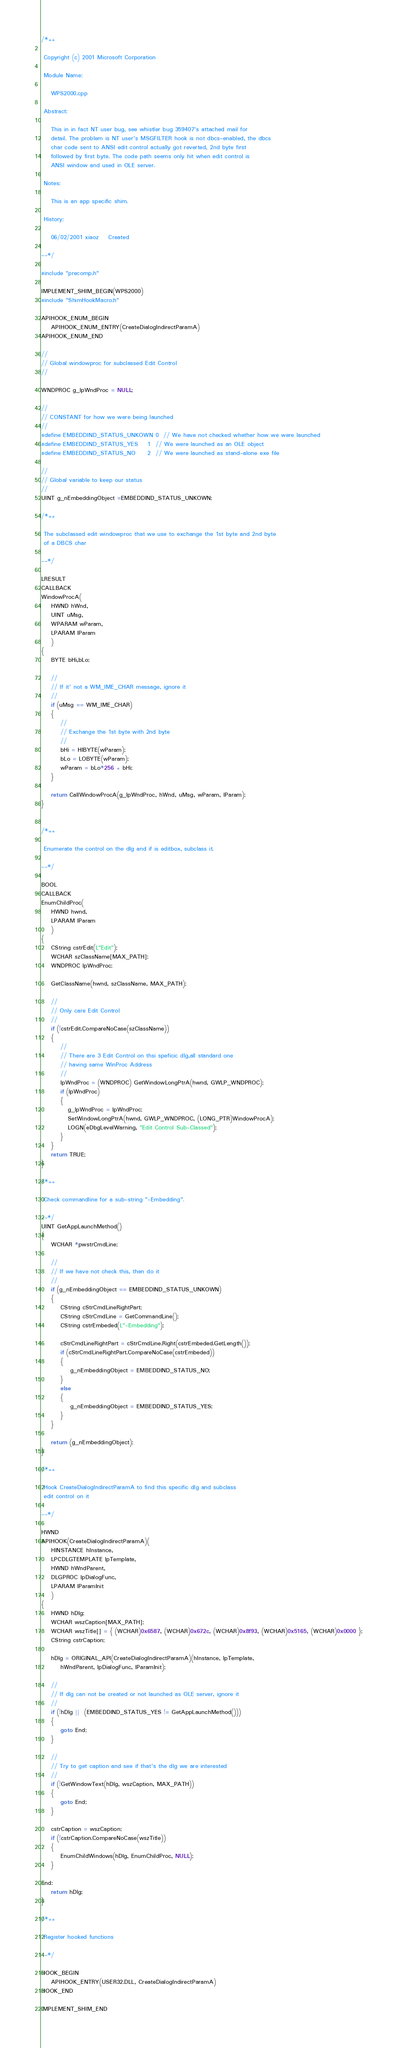<code> <loc_0><loc_0><loc_500><loc_500><_C++_>/*++

 Copyright (c) 2001 Microsoft Corporation

 Module Name:

    WPS2000.cpp

 Abstract:

    This in in fact NT user bug, see whistler bug 359407's attached mail for 
    detail. The problem is NT user's MSGFILTER hook is not dbcs-enabled, the dbcs 
    char code sent to ANSI edit control actually got reverted, 2nd byte first 
    followed by first byte. The code path seems only hit when edit control is 
    ANSI window and used in OLE server.

 Notes: 
  
    This is an app specific shim.

 History:

    06/02/2001 xiaoz    Created

--*/

#include "precomp.h"

IMPLEMENT_SHIM_BEGIN(WPS2000)
#include "ShimHookMacro.h"

APIHOOK_ENUM_BEGIN
    APIHOOK_ENUM_ENTRY(CreateDialogIndirectParamA) 
APIHOOK_ENUM_END

//
// Global windowproc for subclassed Edit Control
//

WNDPROC g_lpWndProc = NULL;

//
// CONSTANT for how we were being launched
//
#define EMBEDDIND_STATUS_UNKOWN 0  // We have not checked whether how we were launched 
#define EMBEDDIND_STATUS_YES    1  // We were launched as an OLE object
#define EMBEDDIND_STATUS_NO     2  // We were launched as stand-alone exe file

//
// Global variable to keep our status
//
UINT g_nEmbeddingObject =EMBEDDIND_STATUS_UNKOWN;

/*++

 The subclassed edit windowproc that we use to exchange the 1st byte and 2nd byte 
 of a DBCS char

--*/

LRESULT
CALLBACK
WindowProcA(
    HWND hWnd, 
    UINT uMsg, 
    WPARAM wParam, 
    LPARAM lParam
    )
{
    BYTE bHi,bLo;

    //
    // If it' not a WM_IME_CHAR message, ignore it
    //
    if (uMsg == WM_IME_CHAR)
    { 
        //
        // Exchange the 1st byte with 2nd byte
        //
        bHi = HIBYTE(wParam);
        bLo = LOBYTE(wParam);
        wParam = bLo*256 + bHi;
    }

    return CallWindowProcA(g_lpWndProc, hWnd, uMsg, wParam, lParam);
}


/*++

 Enumerate the control on the dlg and if is editbox, subclass it.

--*/

BOOL 
CALLBACK 
EnumChildProc(
    HWND hwnd,
    LPARAM lParam 
    )
{
    CString cstrEdit(L"Edit");
    WCHAR szClassName[MAX_PATH];
    WNDPROC lpWndProc;

    GetClassName(hwnd, szClassName, MAX_PATH);

    //
    // Only care Edit Control
    //
    if (!cstrEdit.CompareNoCase(szClassName))
    {
        //
        // There are 3 Edit Control on thsi speficic dlg,all standard one
        // having same WinProc Address
        //
        lpWndProc = (WNDPROC) GetWindowLongPtrA(hwnd, GWLP_WNDPROC);
        if (lpWndProc)
        {
           g_lpWndProc = lpWndProc;
           SetWindowLongPtrA(hwnd, GWLP_WNDPROC, (LONG_PTR)WindowProcA);
           LOGN(eDbgLevelWarning, "Edit Control Sub-Classed");
        }
    }
    return TRUE;
}

/*++

 Check commandline for a sub-string "-Embedding".

--*/
UINT GetAppLaunchMethod()
{
    WCHAR *pwstrCmdLine;
 
    //
    // If we have not check this, then do it 
    //
    if (g_nEmbeddingObject == EMBEDDIND_STATUS_UNKOWN)
    {
        CString cStrCmdLineRightPart;
        CString cStrCmdLine = GetCommandLine();
        CString cstrEmbeded(L"-Embedding");

        cStrCmdLineRightPart = cStrCmdLine.Right(cstrEmbeded.GetLength());
        if (cStrCmdLineRightPart.CompareNoCase(cstrEmbeded))
        {
            g_nEmbeddingObject = EMBEDDIND_STATUS_NO;
        }
        else
        {
            g_nEmbeddingObject = EMBEDDIND_STATUS_YES;
        }
    }

    return (g_nEmbeddingObject);
}

/*++

 Hook CreateDialogIndirectParamA to find this specific dlg and subclass
 edit control on it 

--*/

HWND 
APIHOOK(CreateDialogIndirectParamA)( 
    HINSTANCE hInstance, 
    LPCDLGTEMPLATE lpTemplate, 
    HWND hWndParent, 
    DLGPROC lpDialogFunc, 
    LPARAM lParamInit
    )
{
    HWND hDlg;
    WCHAR wszCaption[MAX_PATH];
    WCHAR wszTitle[] = { (WCHAR)0x6587, (WCHAR)0x672c, (WCHAR)0x8f93, (WCHAR)0x5165, (WCHAR)0x0000 };
    CString cstrCaption;
    
    hDlg = ORIGINAL_API(CreateDialogIndirectParamA)(hInstance, lpTemplate,
        hWndParent, lpDialogFunc, lParamInit);

    //
    // If dlg can not be created or not launched as OLE server, ignore it
    //
    if (!hDlg ||  (EMBEDDIND_STATUS_YES != GetAppLaunchMethod()))
    {
        goto End;
    }

    //
    // Try to get caption and see if that's the dlg we are interested 
    //
    if (!GetWindowText(hDlg, wszCaption, MAX_PATH))
    {
        goto End;
    }

    cstrCaption = wszCaption;
    if (!cstrCaption.CompareNoCase(wszTitle))
    {
        EnumChildWindows(hDlg, EnumChildProc, NULL);
    }

End:
    return hDlg;
}

/*++

 Register hooked functions

--*/

HOOK_BEGIN
    APIHOOK_ENTRY(USER32.DLL, CreateDialogIndirectParamA)        
HOOK_END

IMPLEMENT_SHIM_END

</code> 